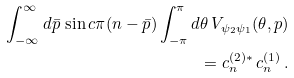<formula> <loc_0><loc_0><loc_500><loc_500>\int _ { - \infty } ^ { \infty } d \bar { p } \, \sin c \pi ( n - \bar { p } ) \int _ { - \pi } ^ { \pi } d \theta \, V _ { \psi _ { 2 } \psi _ { 1 } } ( \theta , p ) \\ = c _ { n } ^ { ( 2 ) \ast } \, c _ { n } ^ { ( 1 ) } \, .</formula> 